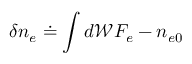Convert formula to latex. <formula><loc_0><loc_0><loc_500><loc_500>\delta { n } _ { e } \doteq \int d \mathcal { W } F _ { e } - n _ { e 0 }</formula> 